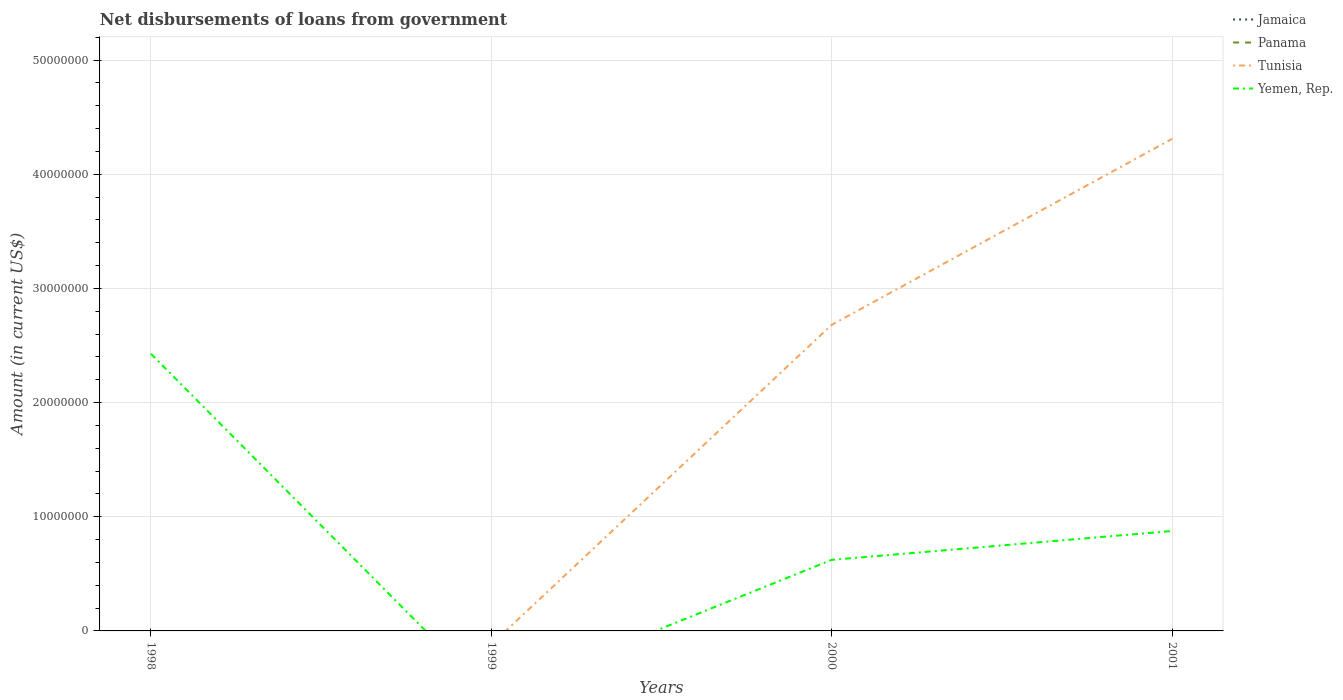How many different coloured lines are there?
Ensure brevity in your answer.  2. Across all years, what is the maximum amount of loan disbursed from government in Panama?
Your answer should be very brief. 0. What is the difference between the highest and the second highest amount of loan disbursed from government in Tunisia?
Offer a terse response. 4.31e+07. What is the difference between the highest and the lowest amount of loan disbursed from government in Jamaica?
Your answer should be compact. 0. How many lines are there?
Offer a terse response. 2. How many years are there in the graph?
Provide a succinct answer. 4. Does the graph contain grids?
Offer a terse response. Yes. Where does the legend appear in the graph?
Give a very brief answer. Top right. What is the title of the graph?
Offer a very short reply. Net disbursements of loans from government. Does "China" appear as one of the legend labels in the graph?
Give a very brief answer. No. What is the label or title of the Y-axis?
Offer a terse response. Amount (in current US$). What is the Amount (in current US$) in Tunisia in 1998?
Keep it short and to the point. 0. What is the Amount (in current US$) of Yemen, Rep. in 1998?
Offer a very short reply. 2.43e+07. What is the Amount (in current US$) in Jamaica in 1999?
Offer a terse response. 0. What is the Amount (in current US$) in Panama in 1999?
Your answer should be very brief. 0. What is the Amount (in current US$) of Tunisia in 1999?
Your response must be concise. 0. What is the Amount (in current US$) of Yemen, Rep. in 1999?
Keep it short and to the point. 0. What is the Amount (in current US$) in Jamaica in 2000?
Give a very brief answer. 0. What is the Amount (in current US$) in Tunisia in 2000?
Provide a short and direct response. 2.68e+07. What is the Amount (in current US$) of Yemen, Rep. in 2000?
Give a very brief answer. 6.22e+06. What is the Amount (in current US$) of Panama in 2001?
Offer a terse response. 0. What is the Amount (in current US$) of Tunisia in 2001?
Provide a succinct answer. 4.31e+07. What is the Amount (in current US$) of Yemen, Rep. in 2001?
Make the answer very short. 8.75e+06. Across all years, what is the maximum Amount (in current US$) in Tunisia?
Provide a short and direct response. 4.31e+07. Across all years, what is the maximum Amount (in current US$) in Yemen, Rep.?
Offer a terse response. 2.43e+07. Across all years, what is the minimum Amount (in current US$) of Tunisia?
Keep it short and to the point. 0. What is the total Amount (in current US$) of Jamaica in the graph?
Keep it short and to the point. 0. What is the total Amount (in current US$) in Tunisia in the graph?
Provide a short and direct response. 6.99e+07. What is the total Amount (in current US$) of Yemen, Rep. in the graph?
Provide a succinct answer. 3.93e+07. What is the difference between the Amount (in current US$) in Yemen, Rep. in 1998 and that in 2000?
Offer a terse response. 1.81e+07. What is the difference between the Amount (in current US$) in Yemen, Rep. in 1998 and that in 2001?
Offer a terse response. 1.55e+07. What is the difference between the Amount (in current US$) of Tunisia in 2000 and that in 2001?
Your answer should be very brief. -1.63e+07. What is the difference between the Amount (in current US$) in Yemen, Rep. in 2000 and that in 2001?
Give a very brief answer. -2.53e+06. What is the difference between the Amount (in current US$) of Tunisia in 2000 and the Amount (in current US$) of Yemen, Rep. in 2001?
Provide a short and direct response. 1.81e+07. What is the average Amount (in current US$) in Tunisia per year?
Offer a very short reply. 1.75e+07. What is the average Amount (in current US$) in Yemen, Rep. per year?
Keep it short and to the point. 9.81e+06. In the year 2000, what is the difference between the Amount (in current US$) in Tunisia and Amount (in current US$) in Yemen, Rep.?
Make the answer very short. 2.06e+07. In the year 2001, what is the difference between the Amount (in current US$) of Tunisia and Amount (in current US$) of Yemen, Rep.?
Make the answer very short. 3.43e+07. What is the ratio of the Amount (in current US$) of Yemen, Rep. in 1998 to that in 2000?
Ensure brevity in your answer.  3.9. What is the ratio of the Amount (in current US$) in Yemen, Rep. in 1998 to that in 2001?
Your response must be concise. 2.77. What is the ratio of the Amount (in current US$) in Tunisia in 2000 to that in 2001?
Give a very brief answer. 0.62. What is the ratio of the Amount (in current US$) of Yemen, Rep. in 2000 to that in 2001?
Your answer should be very brief. 0.71. What is the difference between the highest and the second highest Amount (in current US$) in Yemen, Rep.?
Provide a succinct answer. 1.55e+07. What is the difference between the highest and the lowest Amount (in current US$) of Tunisia?
Give a very brief answer. 4.31e+07. What is the difference between the highest and the lowest Amount (in current US$) of Yemen, Rep.?
Give a very brief answer. 2.43e+07. 